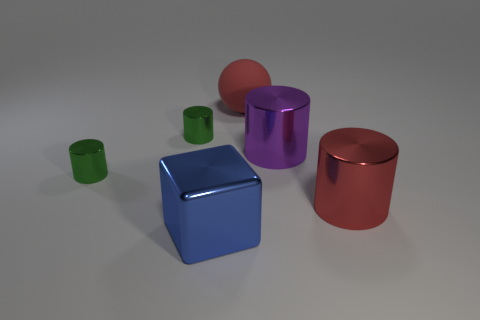What number of other metal objects have the same shape as the blue shiny object?
Make the answer very short. 0. What is the purple thing made of?
Your answer should be compact. Metal. Is the purple metal object the same shape as the blue metallic thing?
Provide a short and direct response. No. Is there another big blue block made of the same material as the blue cube?
Offer a terse response. No. There is a thing that is both behind the purple cylinder and on the left side of the big rubber thing; what color is it?
Ensure brevity in your answer.  Green. There is a large object that is on the left side of the large red matte ball; what material is it?
Provide a succinct answer. Metal. Is there a green rubber object that has the same shape as the purple metal thing?
Your answer should be very brief. No. How many other objects are the same shape as the blue metal object?
Offer a terse response. 0. Is the shape of the blue object the same as the red object that is to the right of the large red rubber sphere?
Your response must be concise. No. Is there anything else that has the same material as the large blue cube?
Offer a very short reply. Yes. 